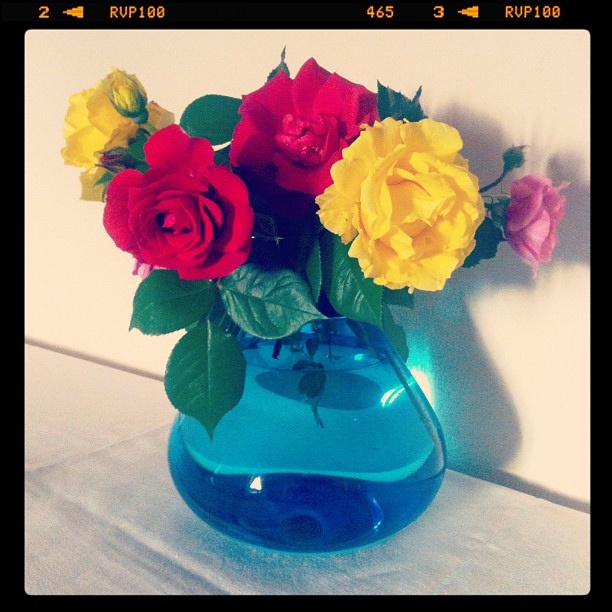Describe the objects in this image and their specific colors. I can see a vase in black, teal, blue, navy, and darkblue tones in this image. 